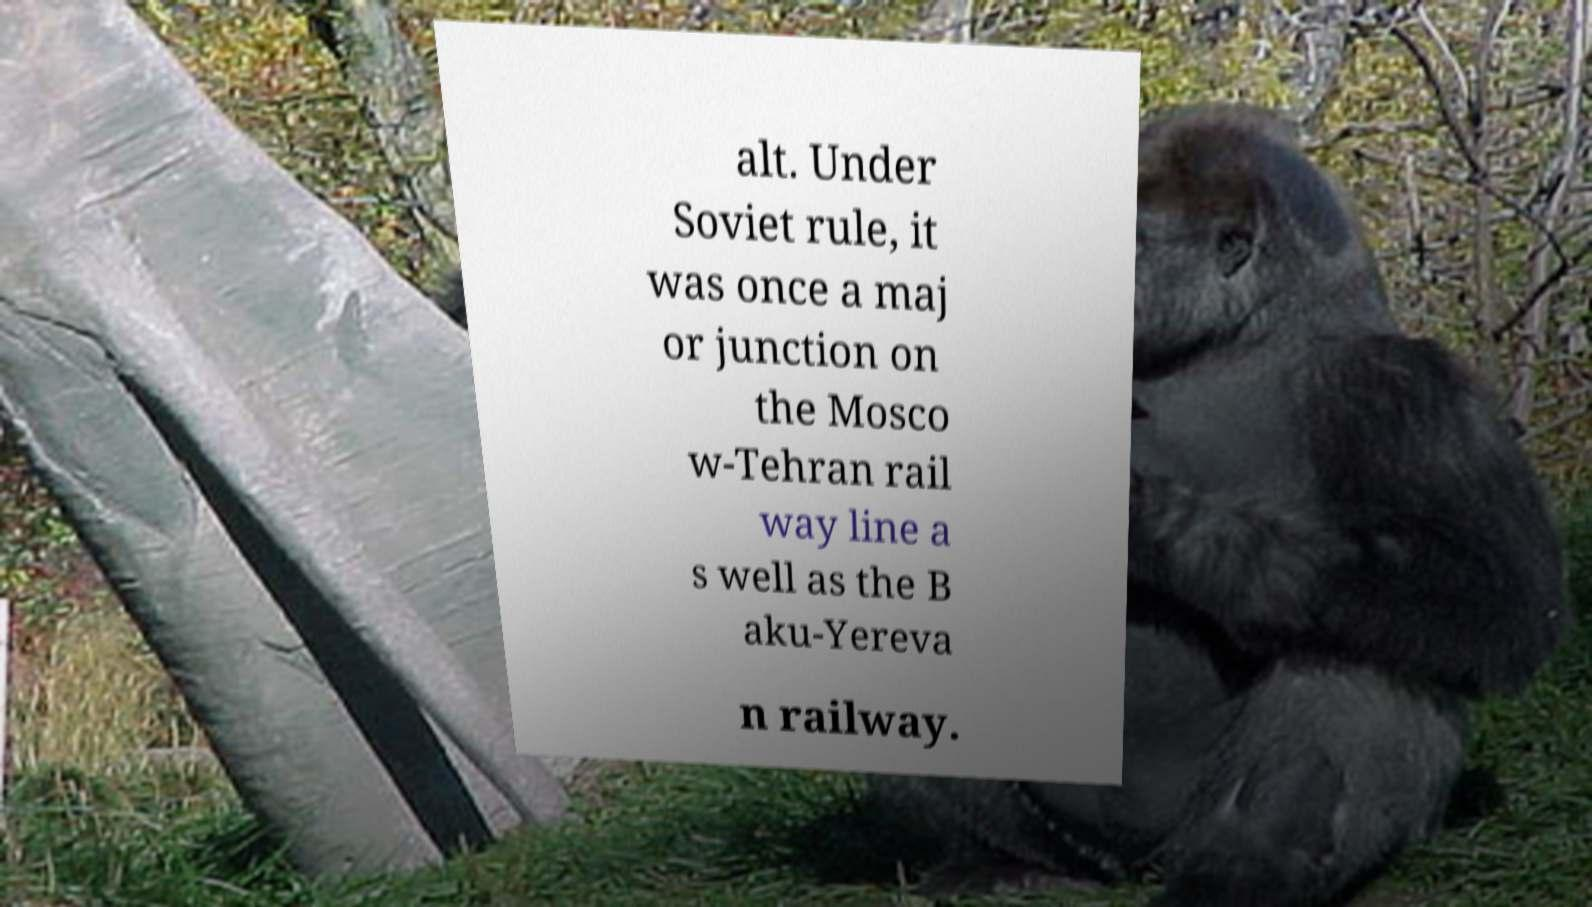There's text embedded in this image that I need extracted. Can you transcribe it verbatim? alt. Under Soviet rule, it was once a maj or junction on the Mosco w-Tehran rail way line a s well as the B aku-Yereva n railway. 